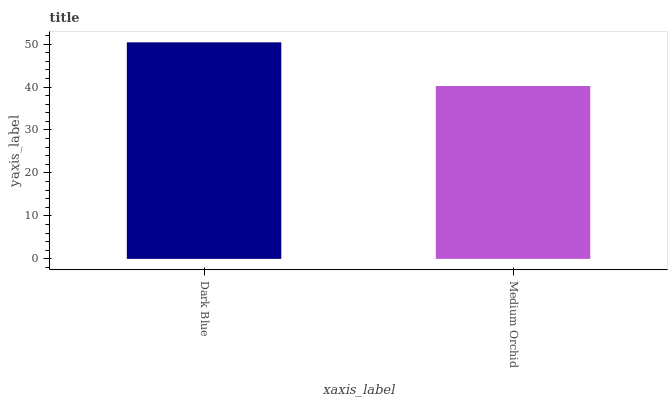Is Medium Orchid the minimum?
Answer yes or no. Yes. Is Dark Blue the maximum?
Answer yes or no. Yes. Is Medium Orchid the maximum?
Answer yes or no. No. Is Dark Blue greater than Medium Orchid?
Answer yes or no. Yes. Is Medium Orchid less than Dark Blue?
Answer yes or no. Yes. Is Medium Orchid greater than Dark Blue?
Answer yes or no. No. Is Dark Blue less than Medium Orchid?
Answer yes or no. No. Is Dark Blue the high median?
Answer yes or no. Yes. Is Medium Orchid the low median?
Answer yes or no. Yes. Is Medium Orchid the high median?
Answer yes or no. No. Is Dark Blue the low median?
Answer yes or no. No. 